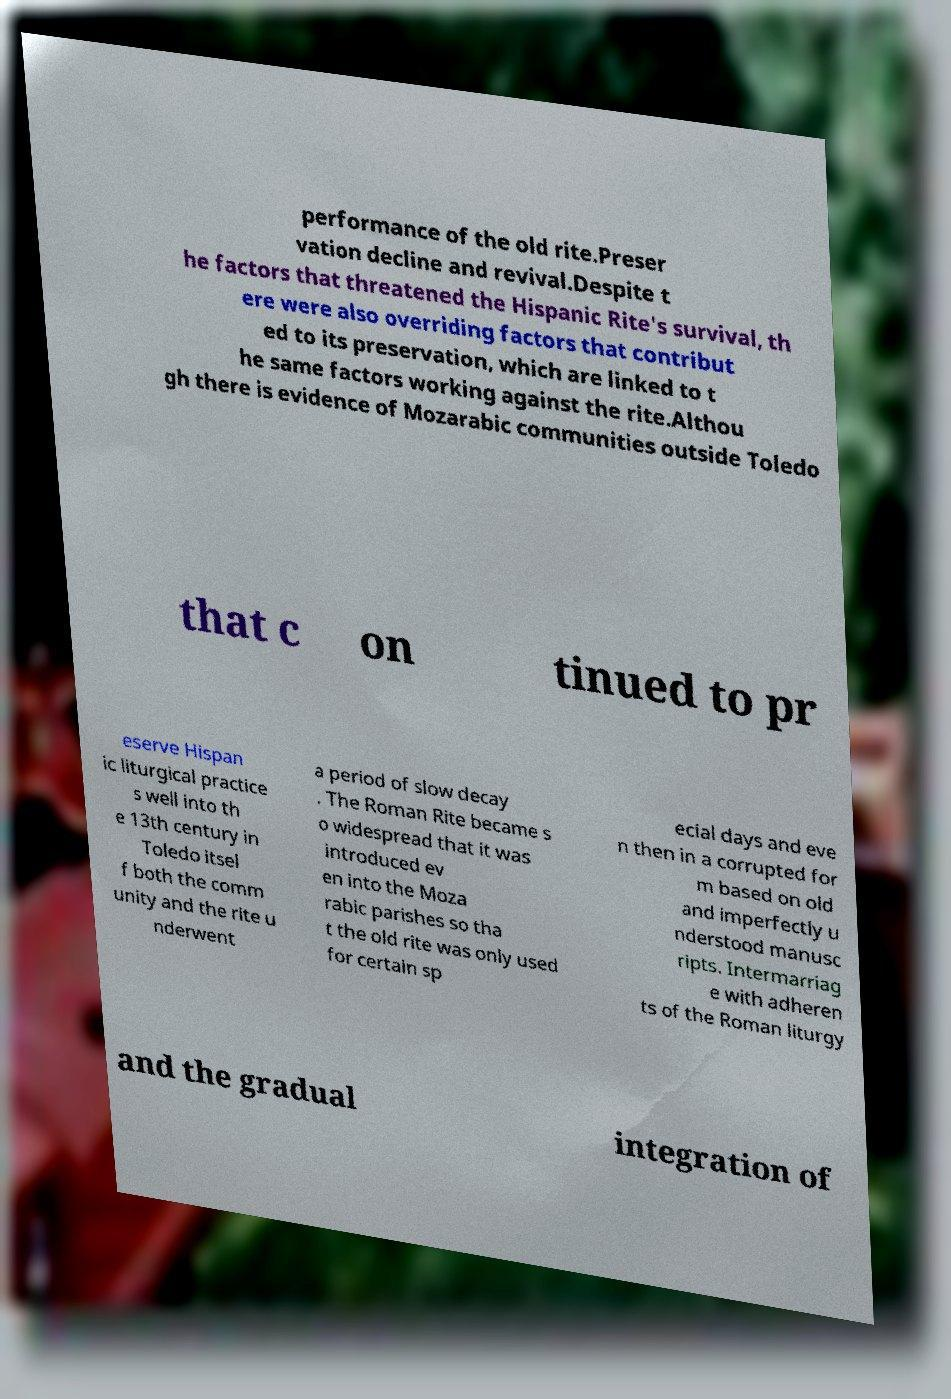Please read and relay the text visible in this image. What does it say? performance of the old rite.Preser vation decline and revival.Despite t he factors that threatened the Hispanic Rite's survival, th ere were also overriding factors that contribut ed to its preservation, which are linked to t he same factors working against the rite.Althou gh there is evidence of Mozarabic communities outside Toledo that c on tinued to pr eserve Hispan ic liturgical practice s well into th e 13th century in Toledo itsel f both the comm unity and the rite u nderwent a period of slow decay . The Roman Rite became s o widespread that it was introduced ev en into the Moza rabic parishes so tha t the old rite was only used for certain sp ecial days and eve n then in a corrupted for m based on old and imperfectly u nderstood manusc ripts. Intermarriag e with adheren ts of the Roman liturgy and the gradual integration of 